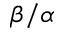Convert formula to latex. <formula><loc_0><loc_0><loc_500><loc_500>\beta / \alpha</formula> 